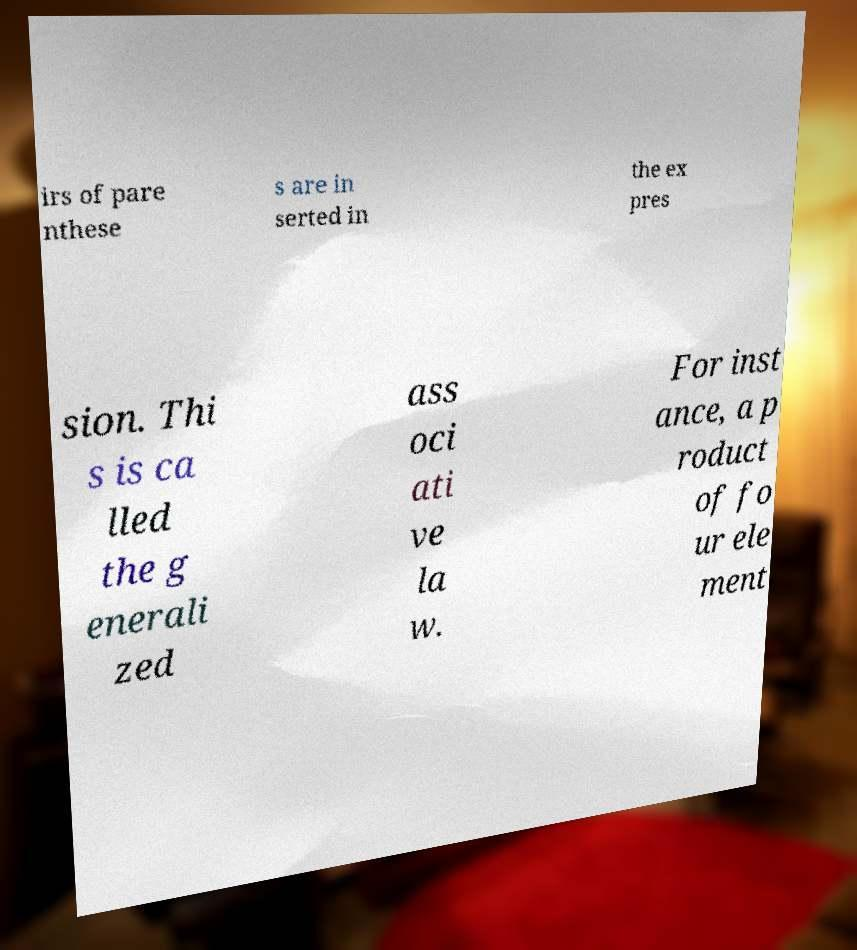There's text embedded in this image that I need extracted. Can you transcribe it verbatim? irs of pare nthese s are in serted in the ex pres sion. Thi s is ca lled the g enerali zed ass oci ati ve la w. For inst ance, a p roduct of fo ur ele ment 